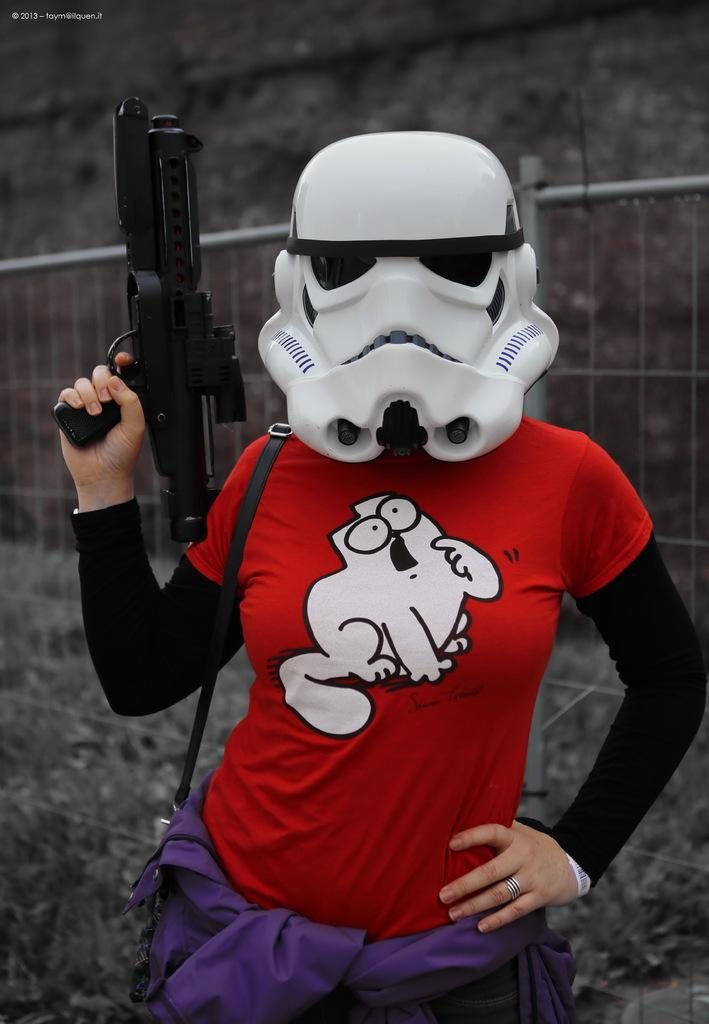Who is present in the image? There is a woman in the image. What is the woman wearing? The woman is wearing a red t-shirt. What is the woman doing in the image? The woman is standing and holding a gun in her hand. What is the woman wearing on her face? The woman is wearing a white color mask. What can be seen in the background of the image? There is fencing and ground visible in the background of the image. Can you see any ocean waves in the image? There is no ocean or waves present in the image. What type of bottle is the woman holding in her hand? The woman is not holding a bottle in her hand; she is holding a gun. 